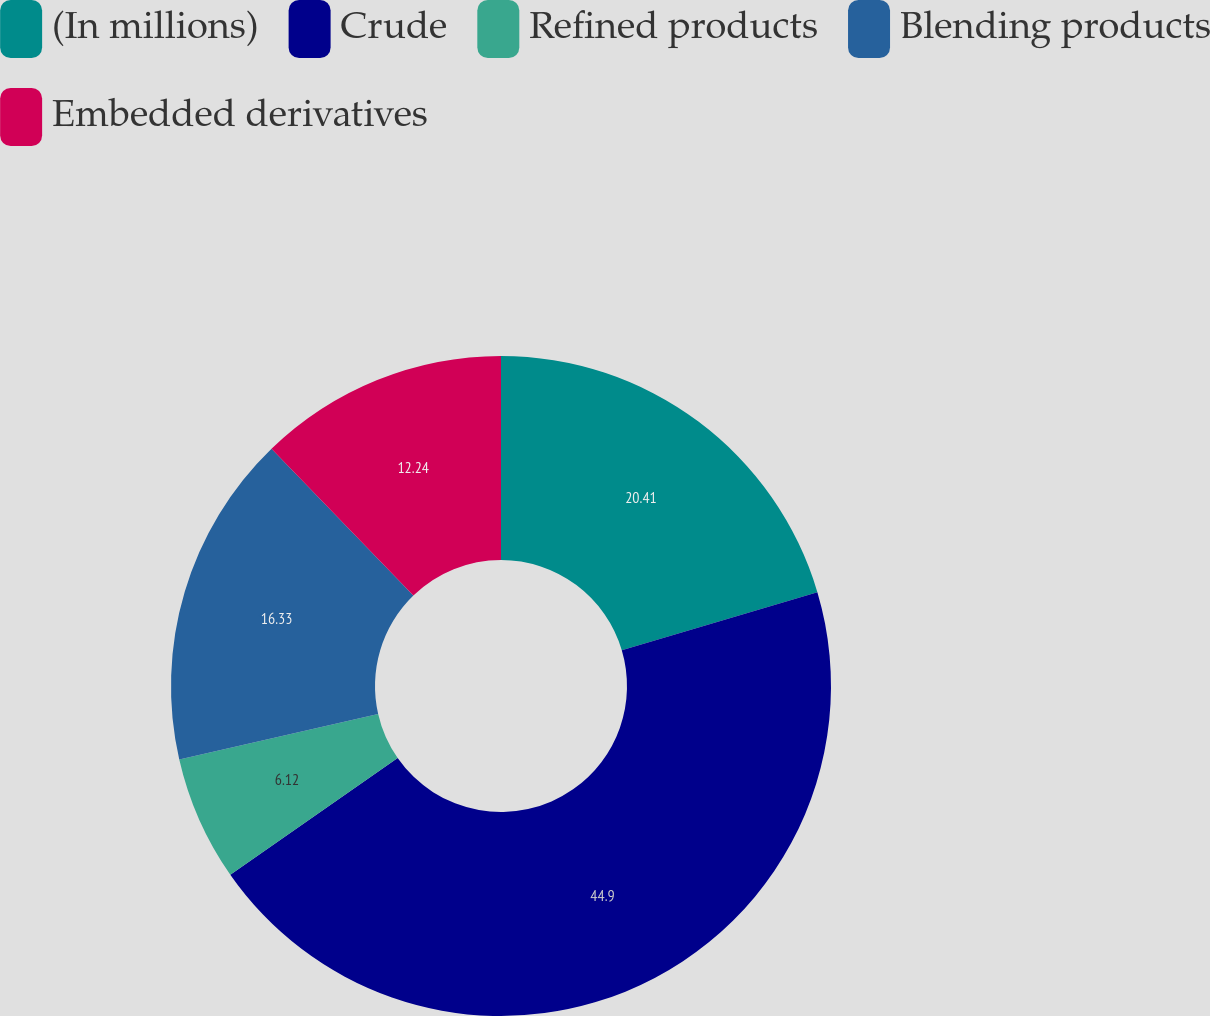Convert chart to OTSL. <chart><loc_0><loc_0><loc_500><loc_500><pie_chart><fcel>(In millions)<fcel>Crude<fcel>Refined products<fcel>Blending products<fcel>Embedded derivatives<nl><fcel>20.41%<fcel>44.9%<fcel>6.12%<fcel>16.33%<fcel>12.24%<nl></chart> 